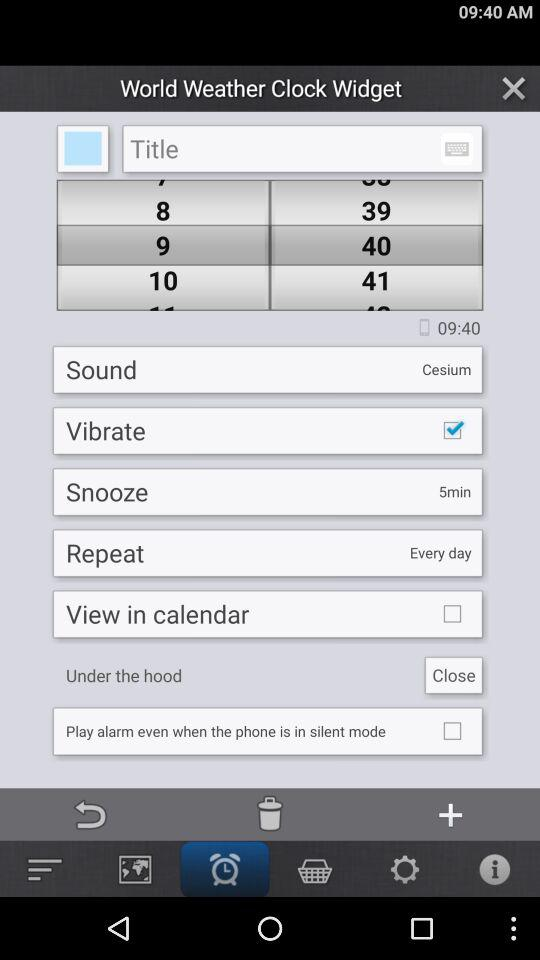What is the setting for repeat? The setting for repeat is "Every day". 